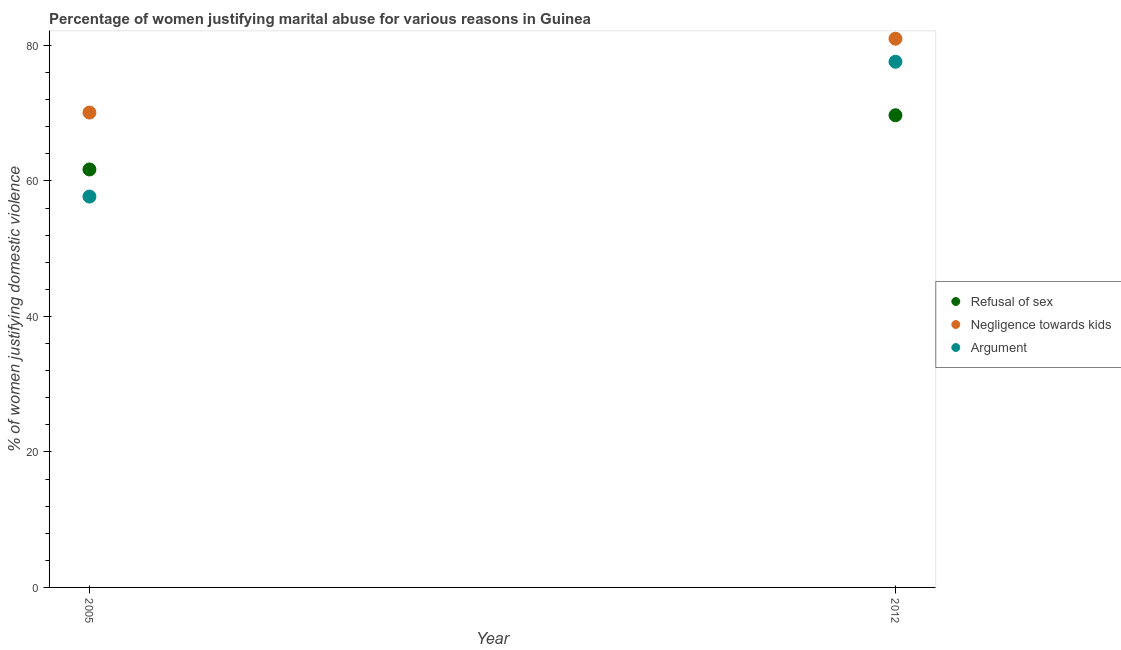Is the number of dotlines equal to the number of legend labels?
Keep it short and to the point. Yes. What is the percentage of women justifying domestic violence due to refusal of sex in 2005?
Keep it short and to the point. 61.7. Across all years, what is the maximum percentage of women justifying domestic violence due to negligence towards kids?
Ensure brevity in your answer.  81. Across all years, what is the minimum percentage of women justifying domestic violence due to negligence towards kids?
Provide a short and direct response. 70.1. In which year was the percentage of women justifying domestic violence due to arguments minimum?
Your answer should be very brief. 2005. What is the total percentage of women justifying domestic violence due to refusal of sex in the graph?
Offer a very short reply. 131.4. What is the difference between the percentage of women justifying domestic violence due to negligence towards kids in 2005 and that in 2012?
Offer a terse response. -10.9. What is the difference between the percentage of women justifying domestic violence due to negligence towards kids in 2012 and the percentage of women justifying domestic violence due to arguments in 2005?
Provide a succinct answer. 23.3. What is the average percentage of women justifying domestic violence due to negligence towards kids per year?
Offer a terse response. 75.55. In the year 2012, what is the difference between the percentage of women justifying domestic violence due to arguments and percentage of women justifying domestic violence due to negligence towards kids?
Offer a terse response. -3.4. What is the ratio of the percentage of women justifying domestic violence due to negligence towards kids in 2005 to that in 2012?
Your answer should be very brief. 0.87. In how many years, is the percentage of women justifying domestic violence due to arguments greater than the average percentage of women justifying domestic violence due to arguments taken over all years?
Keep it short and to the point. 1. How many dotlines are there?
Provide a succinct answer. 3. How many years are there in the graph?
Your response must be concise. 2. Does the graph contain any zero values?
Your response must be concise. No. How are the legend labels stacked?
Keep it short and to the point. Vertical. What is the title of the graph?
Provide a succinct answer. Percentage of women justifying marital abuse for various reasons in Guinea. What is the label or title of the X-axis?
Your answer should be very brief. Year. What is the label or title of the Y-axis?
Provide a short and direct response. % of women justifying domestic violence. What is the % of women justifying domestic violence in Refusal of sex in 2005?
Provide a short and direct response. 61.7. What is the % of women justifying domestic violence of Negligence towards kids in 2005?
Provide a short and direct response. 70.1. What is the % of women justifying domestic violence in Argument in 2005?
Give a very brief answer. 57.7. What is the % of women justifying domestic violence in Refusal of sex in 2012?
Offer a terse response. 69.7. What is the % of women justifying domestic violence of Negligence towards kids in 2012?
Provide a succinct answer. 81. What is the % of women justifying domestic violence of Argument in 2012?
Give a very brief answer. 77.6. Across all years, what is the maximum % of women justifying domestic violence of Refusal of sex?
Provide a short and direct response. 69.7. Across all years, what is the maximum % of women justifying domestic violence of Argument?
Provide a short and direct response. 77.6. Across all years, what is the minimum % of women justifying domestic violence of Refusal of sex?
Your answer should be compact. 61.7. Across all years, what is the minimum % of women justifying domestic violence in Negligence towards kids?
Offer a terse response. 70.1. Across all years, what is the minimum % of women justifying domestic violence in Argument?
Provide a short and direct response. 57.7. What is the total % of women justifying domestic violence in Refusal of sex in the graph?
Your response must be concise. 131.4. What is the total % of women justifying domestic violence of Negligence towards kids in the graph?
Ensure brevity in your answer.  151.1. What is the total % of women justifying domestic violence in Argument in the graph?
Provide a short and direct response. 135.3. What is the difference between the % of women justifying domestic violence in Refusal of sex in 2005 and that in 2012?
Your answer should be compact. -8. What is the difference between the % of women justifying domestic violence of Argument in 2005 and that in 2012?
Keep it short and to the point. -19.9. What is the difference between the % of women justifying domestic violence of Refusal of sex in 2005 and the % of women justifying domestic violence of Negligence towards kids in 2012?
Keep it short and to the point. -19.3. What is the difference between the % of women justifying domestic violence in Refusal of sex in 2005 and the % of women justifying domestic violence in Argument in 2012?
Give a very brief answer. -15.9. What is the difference between the % of women justifying domestic violence in Negligence towards kids in 2005 and the % of women justifying domestic violence in Argument in 2012?
Ensure brevity in your answer.  -7.5. What is the average % of women justifying domestic violence in Refusal of sex per year?
Provide a short and direct response. 65.7. What is the average % of women justifying domestic violence of Negligence towards kids per year?
Offer a terse response. 75.55. What is the average % of women justifying domestic violence of Argument per year?
Provide a short and direct response. 67.65. In the year 2005, what is the difference between the % of women justifying domestic violence in Refusal of sex and % of women justifying domestic violence in Negligence towards kids?
Your answer should be compact. -8.4. In the year 2005, what is the difference between the % of women justifying domestic violence of Refusal of sex and % of women justifying domestic violence of Argument?
Your response must be concise. 4. In the year 2005, what is the difference between the % of women justifying domestic violence of Negligence towards kids and % of women justifying domestic violence of Argument?
Provide a short and direct response. 12.4. In the year 2012, what is the difference between the % of women justifying domestic violence in Negligence towards kids and % of women justifying domestic violence in Argument?
Keep it short and to the point. 3.4. What is the ratio of the % of women justifying domestic violence of Refusal of sex in 2005 to that in 2012?
Your answer should be very brief. 0.89. What is the ratio of the % of women justifying domestic violence of Negligence towards kids in 2005 to that in 2012?
Provide a succinct answer. 0.87. What is the ratio of the % of women justifying domestic violence in Argument in 2005 to that in 2012?
Make the answer very short. 0.74. What is the difference between the highest and the second highest % of women justifying domestic violence of Refusal of sex?
Your answer should be compact. 8. What is the difference between the highest and the second highest % of women justifying domestic violence in Argument?
Keep it short and to the point. 19.9. 